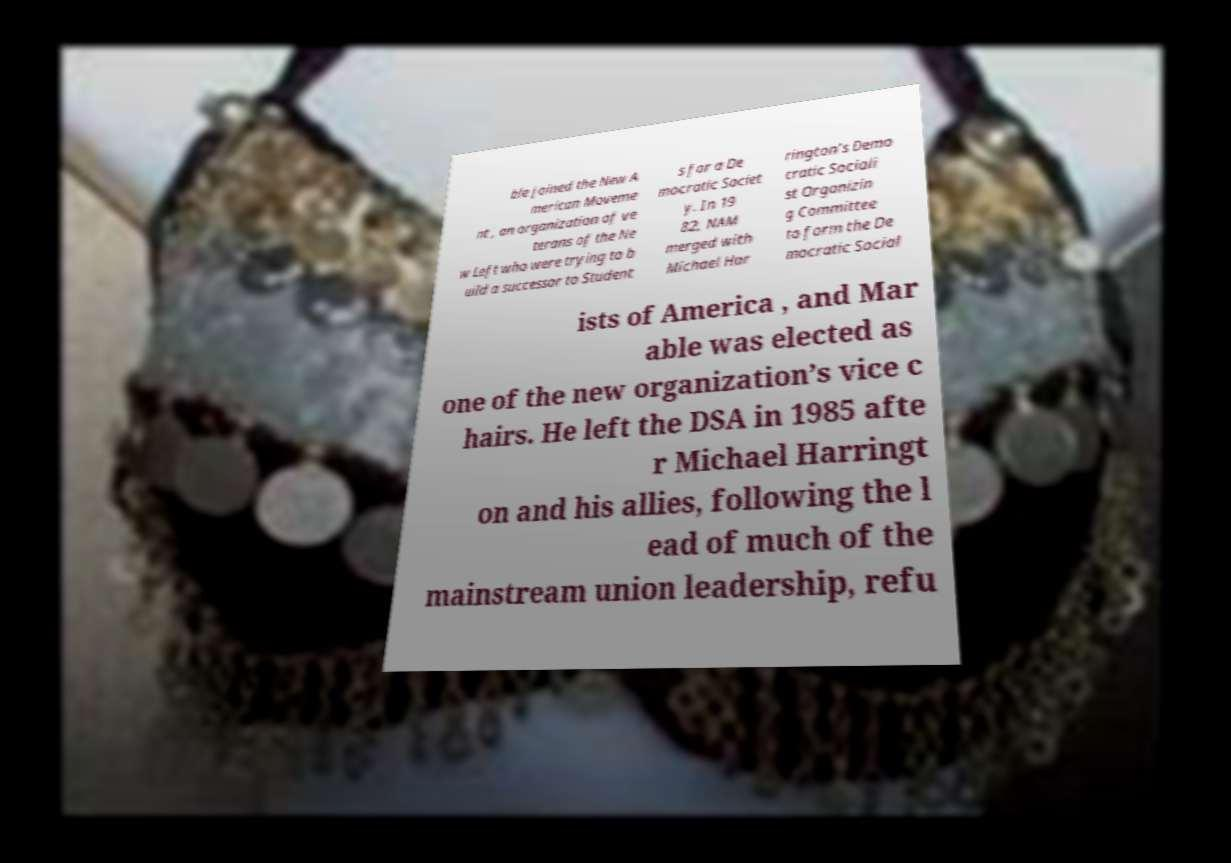Please identify and transcribe the text found in this image. ble joined the New A merican Moveme nt , an organization of ve terans of the Ne w Left who were trying to b uild a successor to Student s for a De mocratic Societ y. In 19 82, NAM merged with Michael Har rington’s Demo cratic Sociali st Organizin g Committee to form the De mocratic Social ists of America , and Mar able was elected as one of the new organization’s vice c hairs. He left the DSA in 1985 afte r Michael Harringt on and his allies, following the l ead of much of the mainstream union leadership, refu 